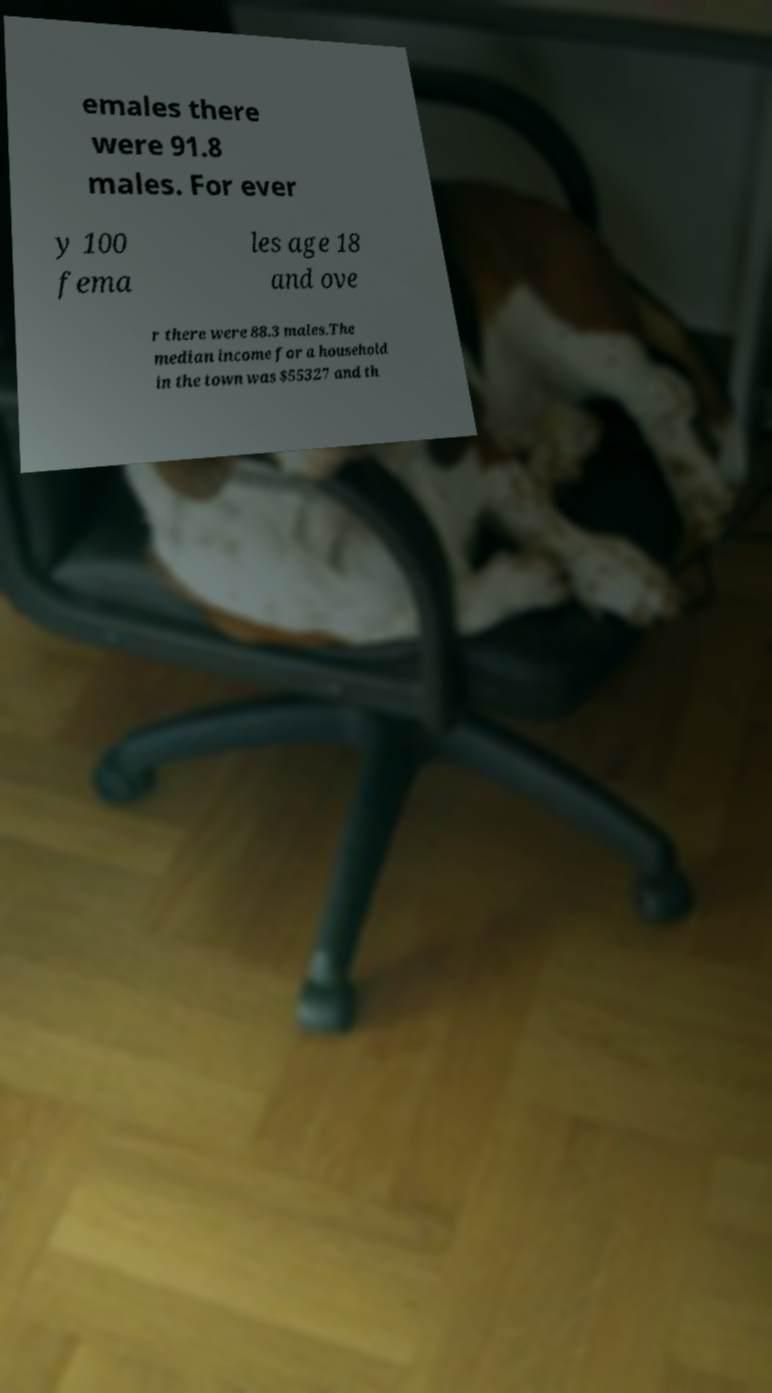What messages or text are displayed in this image? I need them in a readable, typed format. emales there were 91.8 males. For ever y 100 fema les age 18 and ove r there were 88.3 males.The median income for a household in the town was $55327 and th 